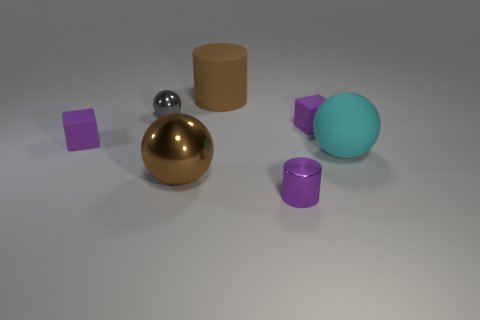There is a brown sphere; is it the same size as the matte block that is left of the purple cylinder?
Provide a succinct answer. No. There is a object that is the same color as the rubber cylinder; what is it made of?
Provide a succinct answer. Metal. There is another sphere that is made of the same material as the tiny sphere; what color is it?
Keep it short and to the point. Brown. How many tiny objects are either brown cylinders or yellow matte blocks?
Ensure brevity in your answer.  0. What number of small purple cylinders are on the left side of the small cylinder?
Keep it short and to the point. 0. What color is the tiny thing that is the same shape as the big cyan object?
Give a very brief answer. Gray. What number of rubber things are either tiny balls or small green objects?
Give a very brief answer. 0. Is there a tiny metal thing in front of the small gray metal ball that is behind the purple cube that is to the left of the rubber cylinder?
Your answer should be compact. Yes. The big cylinder has what color?
Your answer should be compact. Brown. Does the brown thing that is right of the brown shiny thing have the same shape as the large cyan thing?
Ensure brevity in your answer.  No. 